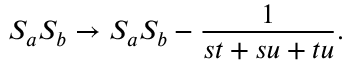Convert formula to latex. <formula><loc_0><loc_0><loc_500><loc_500>{ S _ { a } S _ { b } } \rightarrow S _ { a } S _ { b } - { \frac { 1 } { s t + s u + t u } } .</formula> 